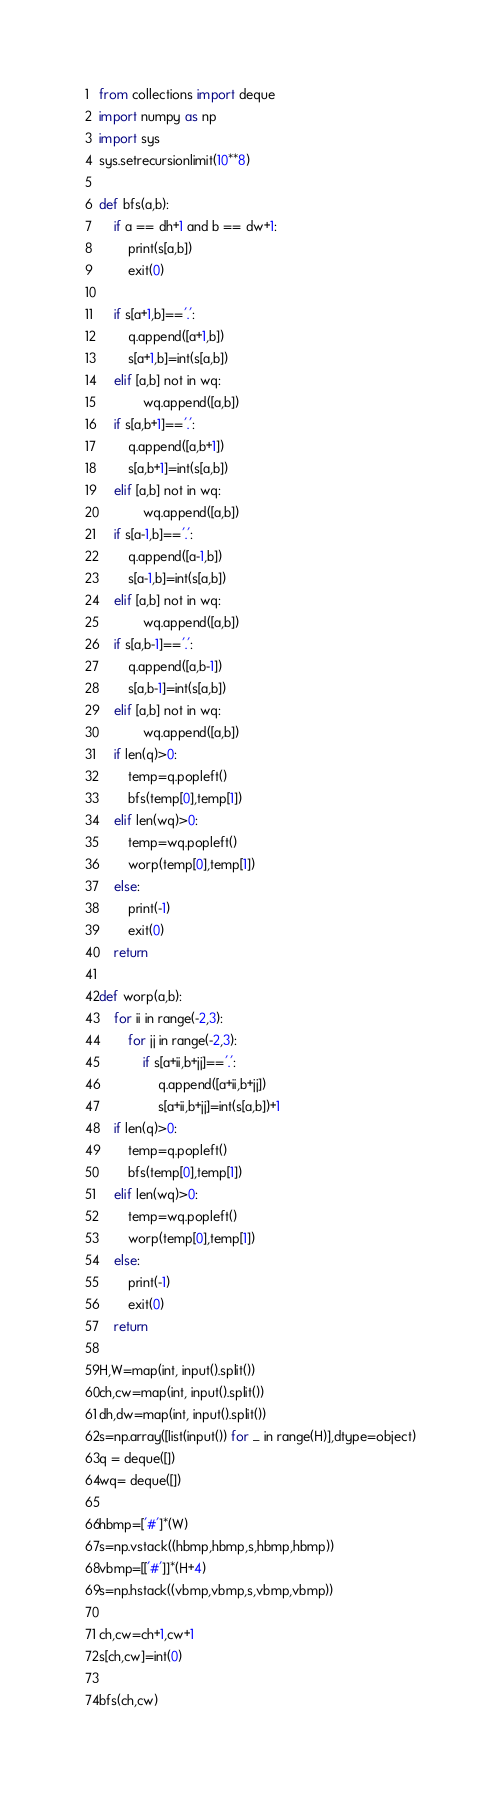Convert code to text. <code><loc_0><loc_0><loc_500><loc_500><_Python_>from collections import deque
import numpy as np
import sys
sys.setrecursionlimit(10**8)

def bfs(a,b):
    if a == dh+1 and b == dw+1:
        print(s[a,b])
        exit(0) 

    if s[a+1,b]=='.': 
        q.append([a+1,b])
        s[a+1,b]=int(s[a,b])
    elif [a,b] not in wq:
            wq.append([a,b])
    if s[a,b+1]=='.':
        q.append([a,b+1])
        s[a,b+1]=int(s[a,b])
    elif [a,b] not in wq:
            wq.append([a,b])
    if s[a-1,b]=='.':
        q.append([a-1,b])
        s[a-1,b]=int(s[a,b])
    elif [a,b] not in wq:
            wq.append([a,b])
    if s[a,b-1]=='.':
        q.append([a,b-1])
        s[a,b-1]=int(s[a,b])
    elif [a,b] not in wq:
            wq.append([a,b])
    if len(q)>0:
        temp=q.popleft()
        bfs(temp[0],temp[1])
    elif len(wq)>0:
        temp=wq.popleft()
        worp(temp[0],temp[1])
    else:
        print(-1)
        exit(0)
    return

def worp(a,b):
    for ii in range(-2,3):
        for jj in range(-2,3):
            if s[a+ii,b+jj]=='.':
                q.append([a+ii,b+jj])
                s[a+ii,b+jj]=int(s[a,b])+1
    if len(q)>0:
        temp=q.popleft()
        bfs(temp[0],temp[1])
    elif len(wq)>0:
        temp=wq.popleft()
        worp(temp[0],temp[1])
    else:
        print(-1)
        exit(0)
    return   

H,W=map(int, input().split())
ch,cw=map(int, input().split())
dh,dw=map(int, input().split())
s=np.array([list(input()) for _ in range(H)],dtype=object)
q = deque([])
wq= deque([])

hbmp=['#']*(W)
s=np.vstack((hbmp,hbmp,s,hbmp,hbmp))
vbmp=[['#']]*(H+4)
s=np.hstack((vbmp,vbmp,s,vbmp,vbmp))

ch,cw=ch+1,cw+1
s[ch,cw]=int(0)

bfs(ch,cw)</code> 